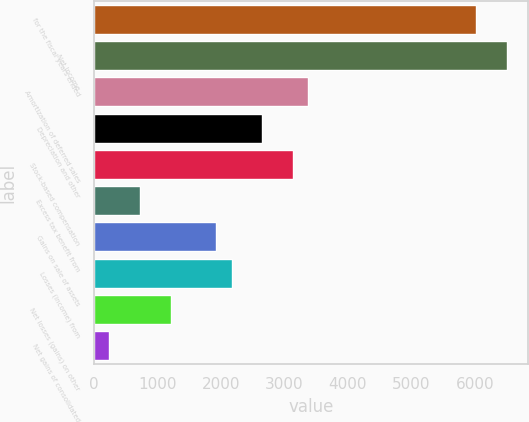<chart> <loc_0><loc_0><loc_500><loc_500><bar_chart><fcel>for the fiscal years ended<fcel>Net Income<fcel>Amortization of deferred sales<fcel>Depreciation and other<fcel>Stock-based compensation<fcel>Excess tax benefit from<fcel>Gains on sale of assets<fcel>Losses (income) from<fcel>Net losses (gains) on other<fcel>Net gains of consolidated<nl><fcel>6025.35<fcel>6507.17<fcel>3375.34<fcel>2652.61<fcel>3134.43<fcel>725.33<fcel>1929.88<fcel>2170.79<fcel>1207.15<fcel>243.51<nl></chart> 